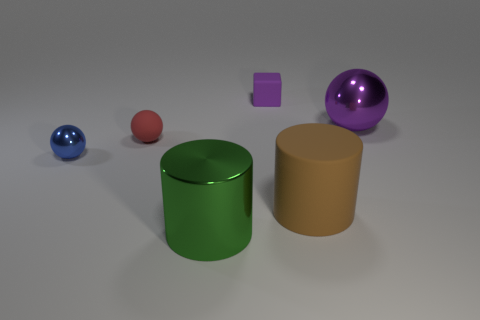Subtract all red balls. How many balls are left? 2 Add 4 big blue shiny cubes. How many objects exist? 10 Subtract all green spheres. Subtract all green cylinders. How many spheres are left? 3 Subtract all blocks. How many objects are left? 5 Add 1 small red objects. How many small red objects exist? 2 Subtract 0 gray cylinders. How many objects are left? 6 Subtract all big green things. Subtract all small red things. How many objects are left? 4 Add 6 green metallic cylinders. How many green metallic cylinders are left? 7 